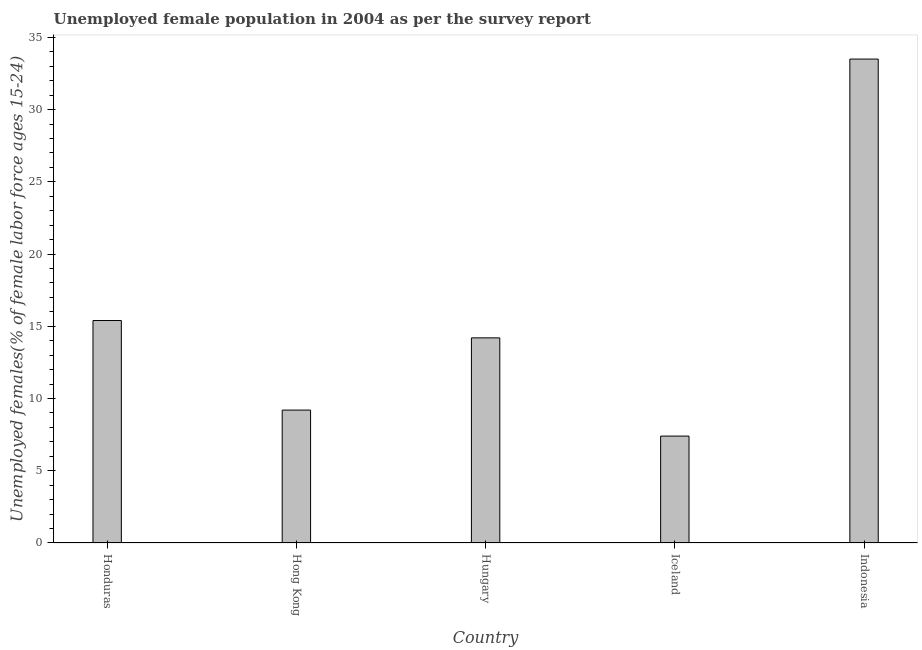Does the graph contain any zero values?
Provide a succinct answer. No. What is the title of the graph?
Keep it short and to the point. Unemployed female population in 2004 as per the survey report. What is the label or title of the X-axis?
Ensure brevity in your answer.  Country. What is the label or title of the Y-axis?
Provide a succinct answer. Unemployed females(% of female labor force ages 15-24). What is the unemployed female youth in Iceland?
Offer a very short reply. 7.4. Across all countries, what is the maximum unemployed female youth?
Keep it short and to the point. 33.5. Across all countries, what is the minimum unemployed female youth?
Make the answer very short. 7.4. In which country was the unemployed female youth maximum?
Make the answer very short. Indonesia. In which country was the unemployed female youth minimum?
Give a very brief answer. Iceland. What is the sum of the unemployed female youth?
Offer a very short reply. 79.7. What is the difference between the unemployed female youth in Honduras and Indonesia?
Your answer should be very brief. -18.1. What is the average unemployed female youth per country?
Your answer should be very brief. 15.94. What is the median unemployed female youth?
Your response must be concise. 14.2. In how many countries, is the unemployed female youth greater than 21 %?
Offer a terse response. 1. What is the ratio of the unemployed female youth in Honduras to that in Hungary?
Your answer should be very brief. 1.08. Is the unemployed female youth in Hungary less than that in Iceland?
Offer a terse response. No. Is the difference between the unemployed female youth in Hungary and Indonesia greater than the difference between any two countries?
Your answer should be very brief. No. What is the difference between the highest and the lowest unemployed female youth?
Give a very brief answer. 26.1. In how many countries, is the unemployed female youth greater than the average unemployed female youth taken over all countries?
Ensure brevity in your answer.  1. How many countries are there in the graph?
Provide a short and direct response. 5. What is the Unemployed females(% of female labor force ages 15-24) of Honduras?
Your answer should be compact. 15.4. What is the Unemployed females(% of female labor force ages 15-24) of Hong Kong?
Keep it short and to the point. 9.2. What is the Unemployed females(% of female labor force ages 15-24) in Hungary?
Keep it short and to the point. 14.2. What is the Unemployed females(% of female labor force ages 15-24) in Iceland?
Make the answer very short. 7.4. What is the Unemployed females(% of female labor force ages 15-24) in Indonesia?
Provide a succinct answer. 33.5. What is the difference between the Unemployed females(% of female labor force ages 15-24) in Honduras and Hong Kong?
Give a very brief answer. 6.2. What is the difference between the Unemployed females(% of female labor force ages 15-24) in Honduras and Hungary?
Your response must be concise. 1.2. What is the difference between the Unemployed females(% of female labor force ages 15-24) in Honduras and Iceland?
Ensure brevity in your answer.  8. What is the difference between the Unemployed females(% of female labor force ages 15-24) in Honduras and Indonesia?
Make the answer very short. -18.1. What is the difference between the Unemployed females(% of female labor force ages 15-24) in Hong Kong and Hungary?
Provide a succinct answer. -5. What is the difference between the Unemployed females(% of female labor force ages 15-24) in Hong Kong and Indonesia?
Offer a very short reply. -24.3. What is the difference between the Unemployed females(% of female labor force ages 15-24) in Hungary and Iceland?
Provide a short and direct response. 6.8. What is the difference between the Unemployed females(% of female labor force ages 15-24) in Hungary and Indonesia?
Provide a succinct answer. -19.3. What is the difference between the Unemployed females(% of female labor force ages 15-24) in Iceland and Indonesia?
Your answer should be compact. -26.1. What is the ratio of the Unemployed females(% of female labor force ages 15-24) in Honduras to that in Hong Kong?
Offer a very short reply. 1.67. What is the ratio of the Unemployed females(% of female labor force ages 15-24) in Honduras to that in Hungary?
Provide a short and direct response. 1.08. What is the ratio of the Unemployed females(% of female labor force ages 15-24) in Honduras to that in Iceland?
Offer a very short reply. 2.08. What is the ratio of the Unemployed females(% of female labor force ages 15-24) in Honduras to that in Indonesia?
Give a very brief answer. 0.46. What is the ratio of the Unemployed females(% of female labor force ages 15-24) in Hong Kong to that in Hungary?
Provide a succinct answer. 0.65. What is the ratio of the Unemployed females(% of female labor force ages 15-24) in Hong Kong to that in Iceland?
Make the answer very short. 1.24. What is the ratio of the Unemployed females(% of female labor force ages 15-24) in Hong Kong to that in Indonesia?
Offer a terse response. 0.28. What is the ratio of the Unemployed females(% of female labor force ages 15-24) in Hungary to that in Iceland?
Your answer should be compact. 1.92. What is the ratio of the Unemployed females(% of female labor force ages 15-24) in Hungary to that in Indonesia?
Keep it short and to the point. 0.42. What is the ratio of the Unemployed females(% of female labor force ages 15-24) in Iceland to that in Indonesia?
Your response must be concise. 0.22. 